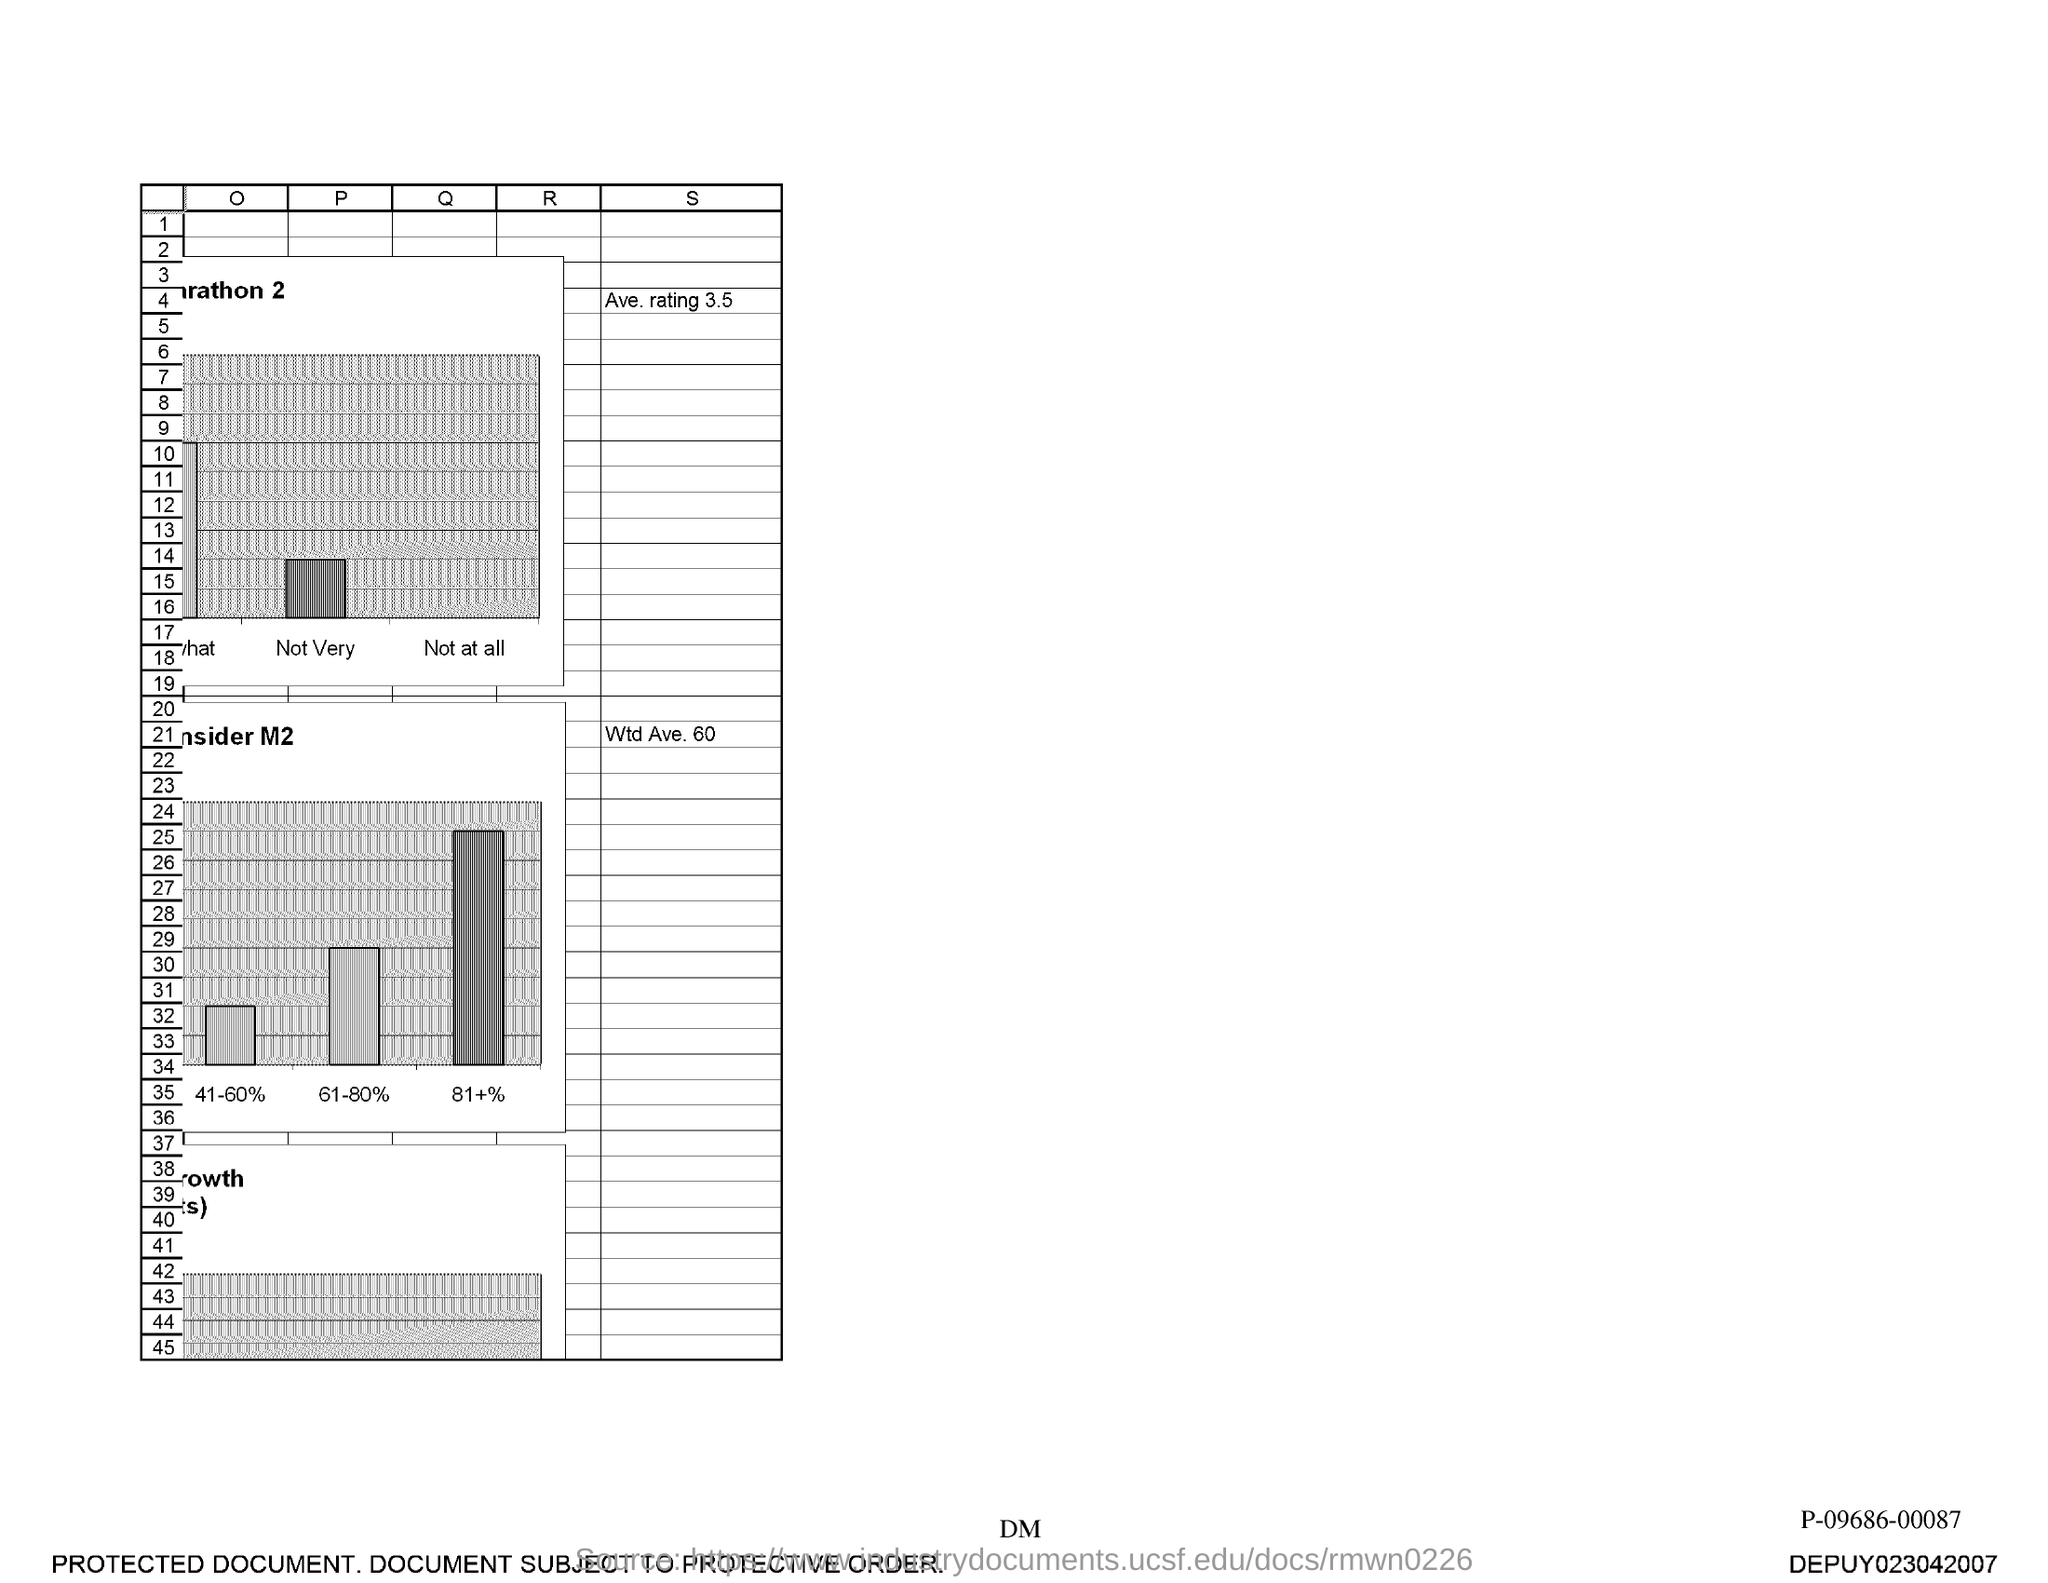What is the last number in the first column?
Ensure brevity in your answer.  45. 